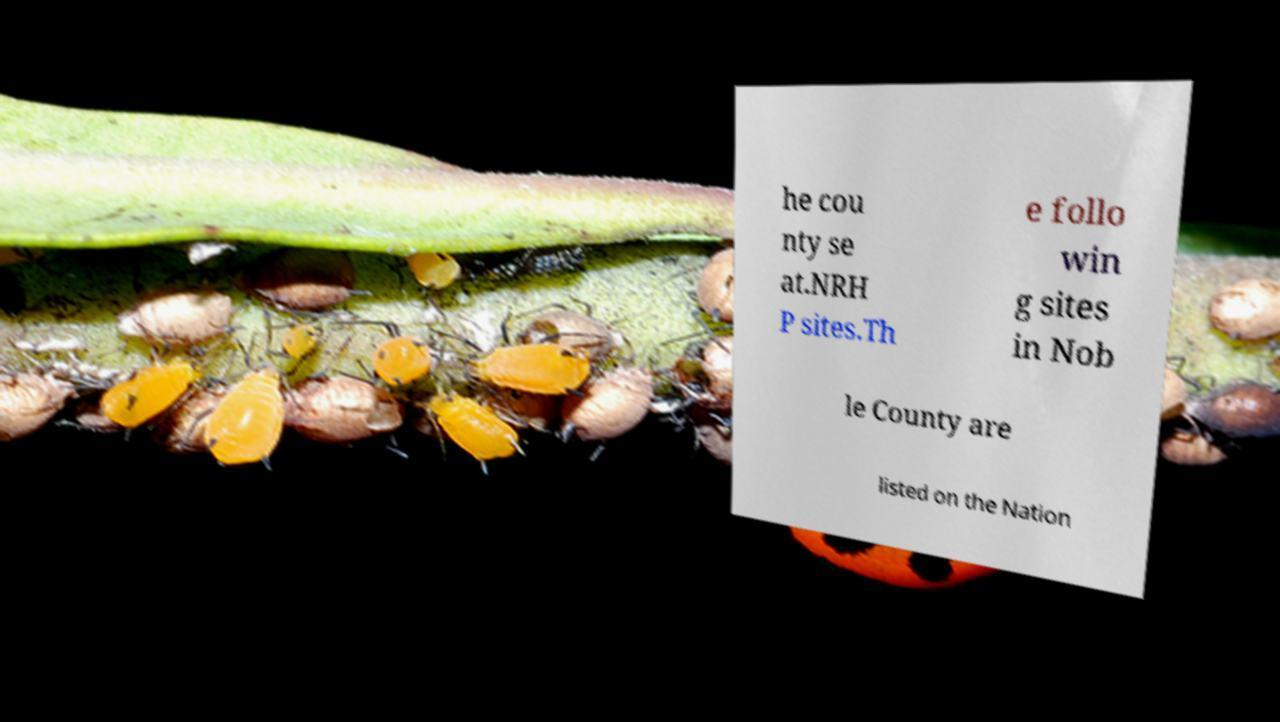For documentation purposes, I need the text within this image transcribed. Could you provide that? he cou nty se at.NRH P sites.Th e follo win g sites in Nob le County are listed on the Nation 